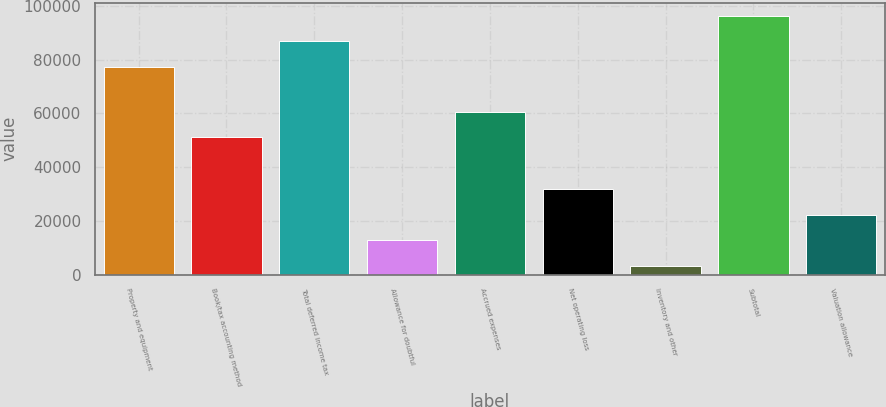Convert chart. <chart><loc_0><loc_0><loc_500><loc_500><bar_chart><fcel>Property and equipment<fcel>Book/tax accounting method<fcel>Total deferred income tax<fcel>Allowance for doubtful<fcel>Accrued expenses<fcel>Net operating loss<fcel>Inventory and other<fcel>Subtotal<fcel>Valuation allowance<nl><fcel>77199<fcel>51096<fcel>86775.8<fcel>12788.8<fcel>60672.8<fcel>31942.4<fcel>3212<fcel>96352.6<fcel>22365.6<nl></chart> 